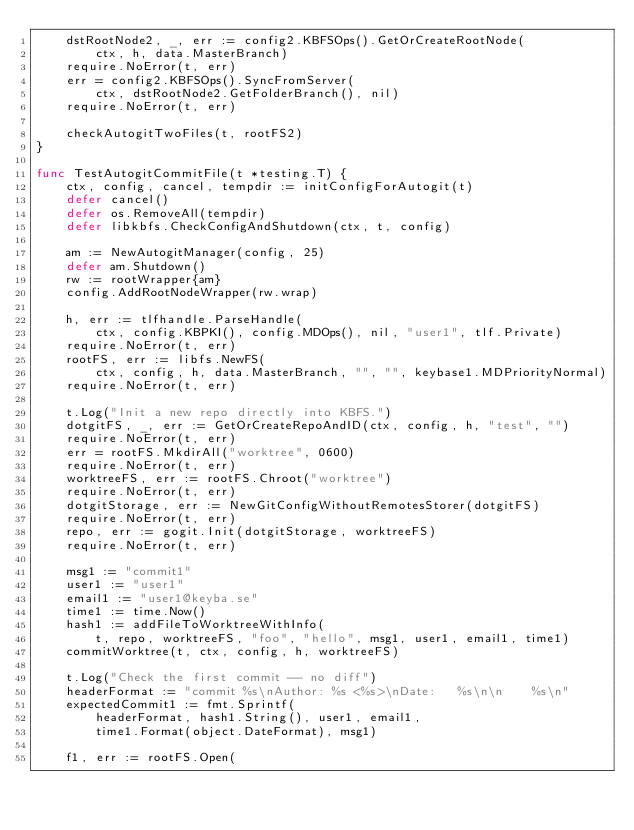<code> <loc_0><loc_0><loc_500><loc_500><_Go_>	dstRootNode2, _, err := config2.KBFSOps().GetOrCreateRootNode(
		ctx, h, data.MasterBranch)
	require.NoError(t, err)
	err = config2.KBFSOps().SyncFromServer(
		ctx, dstRootNode2.GetFolderBranch(), nil)
	require.NoError(t, err)

	checkAutogitTwoFiles(t, rootFS2)
}

func TestAutogitCommitFile(t *testing.T) {
	ctx, config, cancel, tempdir := initConfigForAutogit(t)
	defer cancel()
	defer os.RemoveAll(tempdir)
	defer libkbfs.CheckConfigAndShutdown(ctx, t, config)

	am := NewAutogitManager(config, 25)
	defer am.Shutdown()
	rw := rootWrapper{am}
	config.AddRootNodeWrapper(rw.wrap)

	h, err := tlfhandle.ParseHandle(
		ctx, config.KBPKI(), config.MDOps(), nil, "user1", tlf.Private)
	require.NoError(t, err)
	rootFS, err := libfs.NewFS(
		ctx, config, h, data.MasterBranch, "", "", keybase1.MDPriorityNormal)
	require.NoError(t, err)

	t.Log("Init a new repo directly into KBFS.")
	dotgitFS, _, err := GetOrCreateRepoAndID(ctx, config, h, "test", "")
	require.NoError(t, err)
	err = rootFS.MkdirAll("worktree", 0600)
	require.NoError(t, err)
	worktreeFS, err := rootFS.Chroot("worktree")
	require.NoError(t, err)
	dotgitStorage, err := NewGitConfigWithoutRemotesStorer(dotgitFS)
	require.NoError(t, err)
	repo, err := gogit.Init(dotgitStorage, worktreeFS)
	require.NoError(t, err)

	msg1 := "commit1"
	user1 := "user1"
	email1 := "user1@keyba.se"
	time1 := time.Now()
	hash1 := addFileToWorktreeWithInfo(
		t, repo, worktreeFS, "foo", "hello", msg1, user1, email1, time1)
	commitWorktree(t, ctx, config, h, worktreeFS)

	t.Log("Check the first commit -- no diff")
	headerFormat := "commit %s\nAuthor: %s <%s>\nDate:   %s\n\n    %s\n"
	expectedCommit1 := fmt.Sprintf(
		headerFormat, hash1.String(), user1, email1,
		time1.Format(object.DateFormat), msg1)

	f1, err := rootFS.Open(</code> 